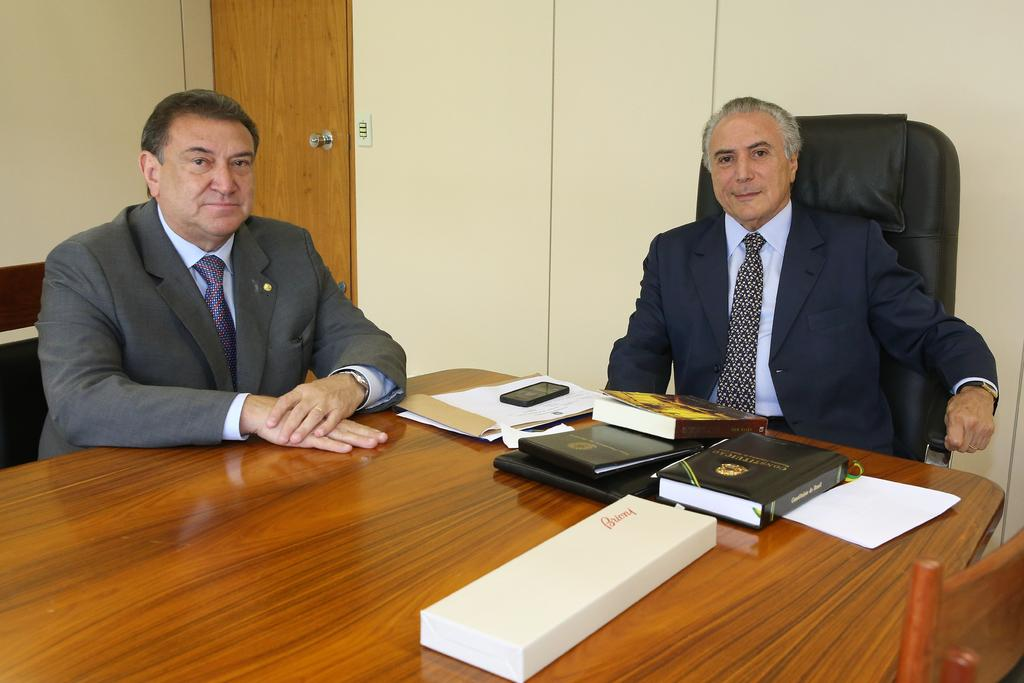How many people are in the image? There are two men in the image. What are the men doing in the image? The men are sitting at a table. What objects can be seen on the table? There are books on the table. What type of hat is the man wearing in the image? There is no hat visible in the image; both men are wearing shirts and pants. 